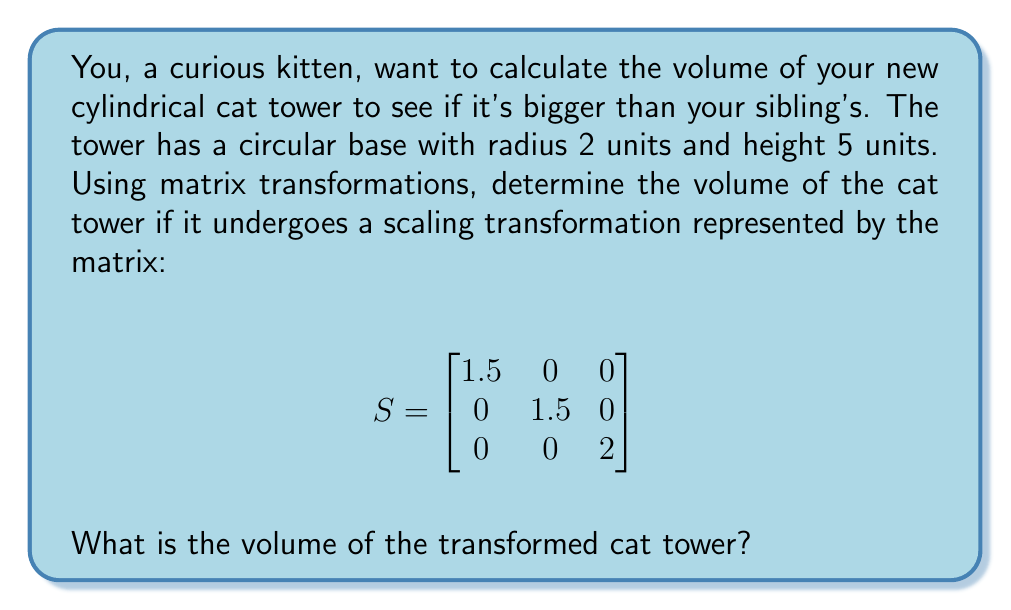Could you help me with this problem? Let's approach this step-by-step:

1) First, recall the formula for the volume of a cylinder:
   $$ V = \pi r^2 h $$
   where $r$ is the radius and $h$ is the height.

2) Initially, the cat tower has:
   radius $r = 2$ units
   height $h = 5$ units

3) The scaling matrix $S$ will transform the cylinder. Let's see how it affects the dimensions:
   - The x and y dimensions (which affect the radius) are scaled by 1.5
   - The z dimension (which affects the height) is scaled by 2

4) After transformation:
   new radius $r' = 1.5 \times 2 = 3$ units
   new height $h' = 2 \times 5 = 10$ units

5) Now we can calculate the new volume:
   $$ V' = \pi (r')^2 h' $$
   $$ V' = \pi (3)^2 (10) $$
   $$ V' = 90\pi $$

6) To get a numerical value, we can use $\pi \approx 3.14159$:
   $$ V' \approx 90 \times 3.14159 \approx 282.74 \text{ cubic units} $$
Answer: The volume of the transformed cat tower is $90\pi$ cubic units, or approximately 282.74 cubic units. 